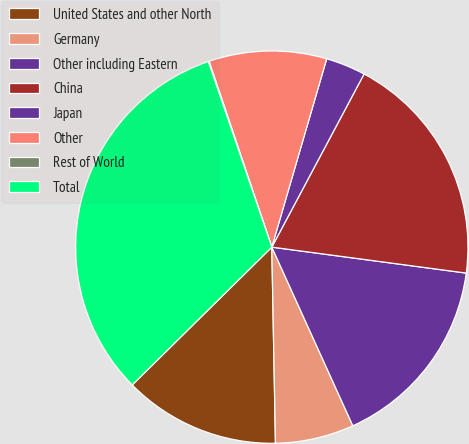<chart> <loc_0><loc_0><loc_500><loc_500><pie_chart><fcel>United States and other North<fcel>Germany<fcel>Other including Eastern<fcel>China<fcel>Japan<fcel>Other<fcel>Rest of World<fcel>Total<nl><fcel>12.9%<fcel>6.48%<fcel>16.11%<fcel>19.32%<fcel>3.28%<fcel>9.69%<fcel>0.07%<fcel>32.15%<nl></chart> 